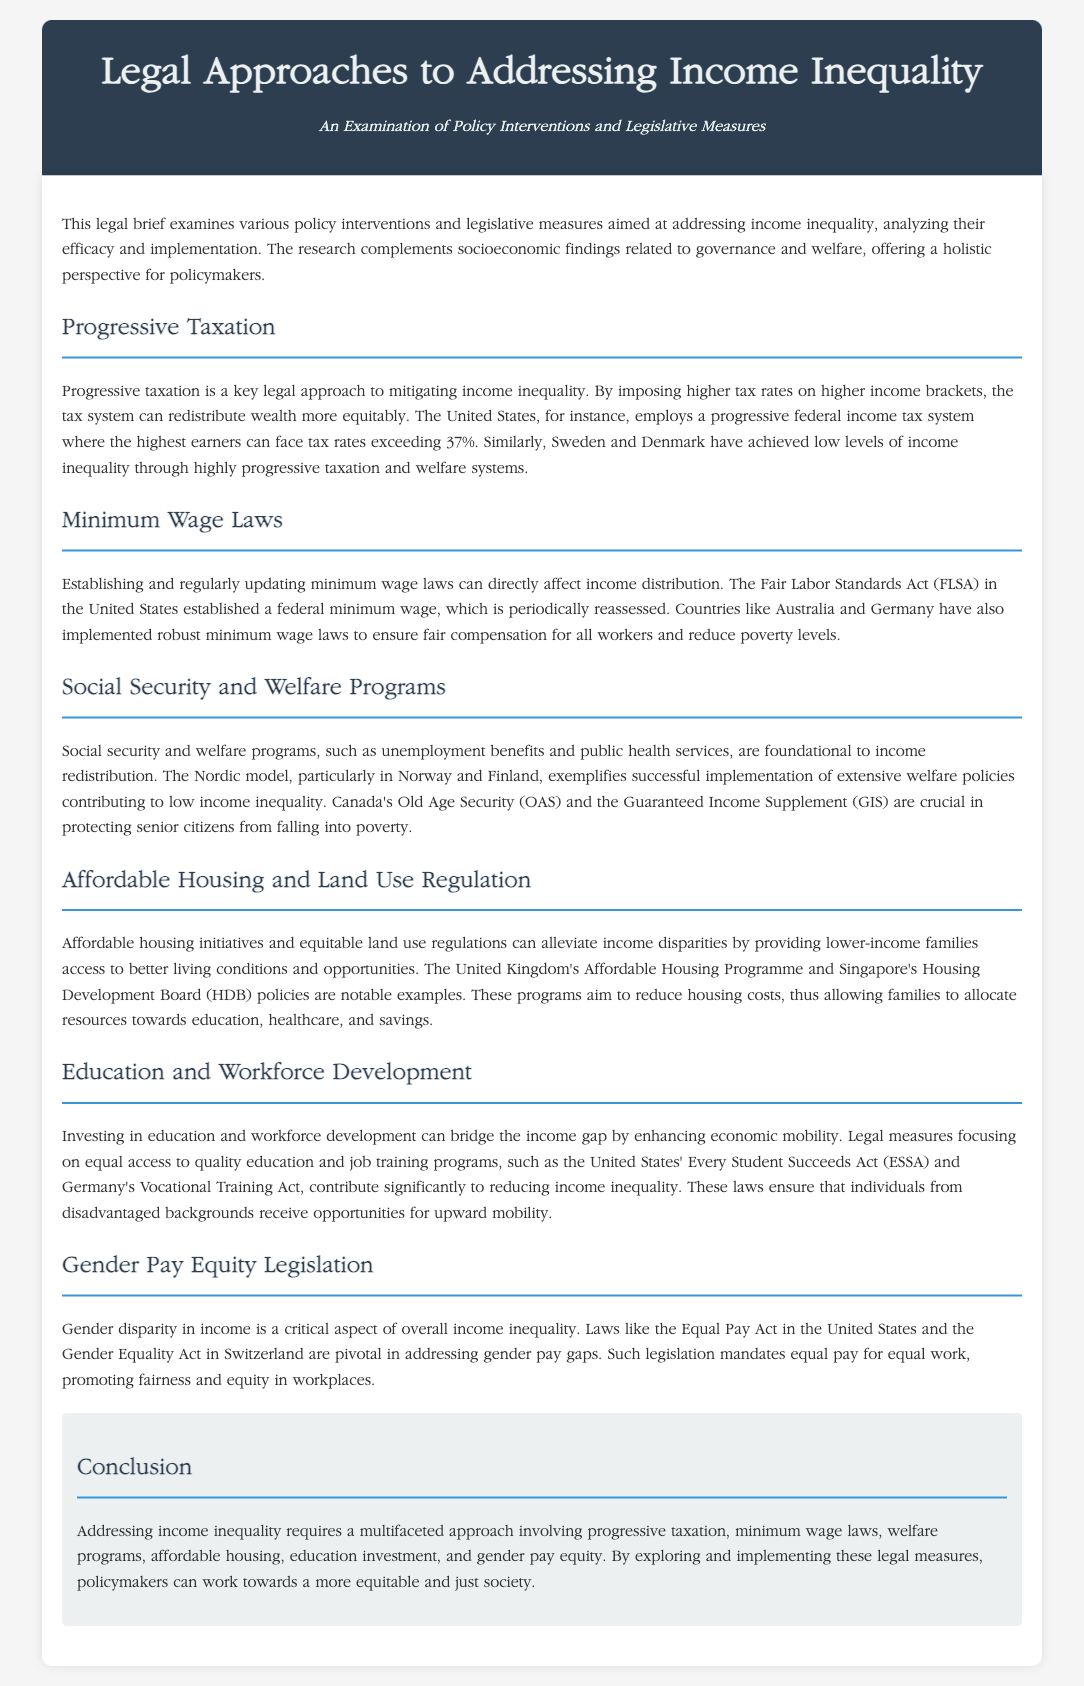what is the primary focus of the legal brief? The legal brief examines various policy interventions and legislative measures aimed at addressing income inequality.
Answer: income inequality which tax system is highlighted as a legal approach in the document? The document discusses progressive taxation as a key legal approach to mitigating income inequality.
Answer: progressive taxation what is mentioned as a foundational component of income redistribution? The document states social security and welfare programs are foundational to income redistribution.
Answer: social security and welfare programs which country's model exemplifies successful implementation of extensive welfare policies? The Nordic model, particularly in Norway and Finland, exemplifies successful implementation of extensive welfare policies.
Answer: Norway and Finland what legal measure is aimed at enhancing economic mobility? The document mentions investing in education and workforce development as a legal measure to enhance economic mobility.
Answer: education and workforce development which act addresses gender pay gaps in the United States? The Equal Pay Act is highlighted as a legislation that addresses gender pay gaps in the United States.
Answer: Equal Pay Act how does the document propose to support lower-income families through housing initiatives? The document suggests that affordable housing initiatives aim to provide lower-income families access to better living conditions.
Answer: affordable housing initiatives what is the top recommended approach to addressing income inequality? The conclusion indicates that addressing income inequality requires a multifaceted approach.
Answer: multifaceted approach 